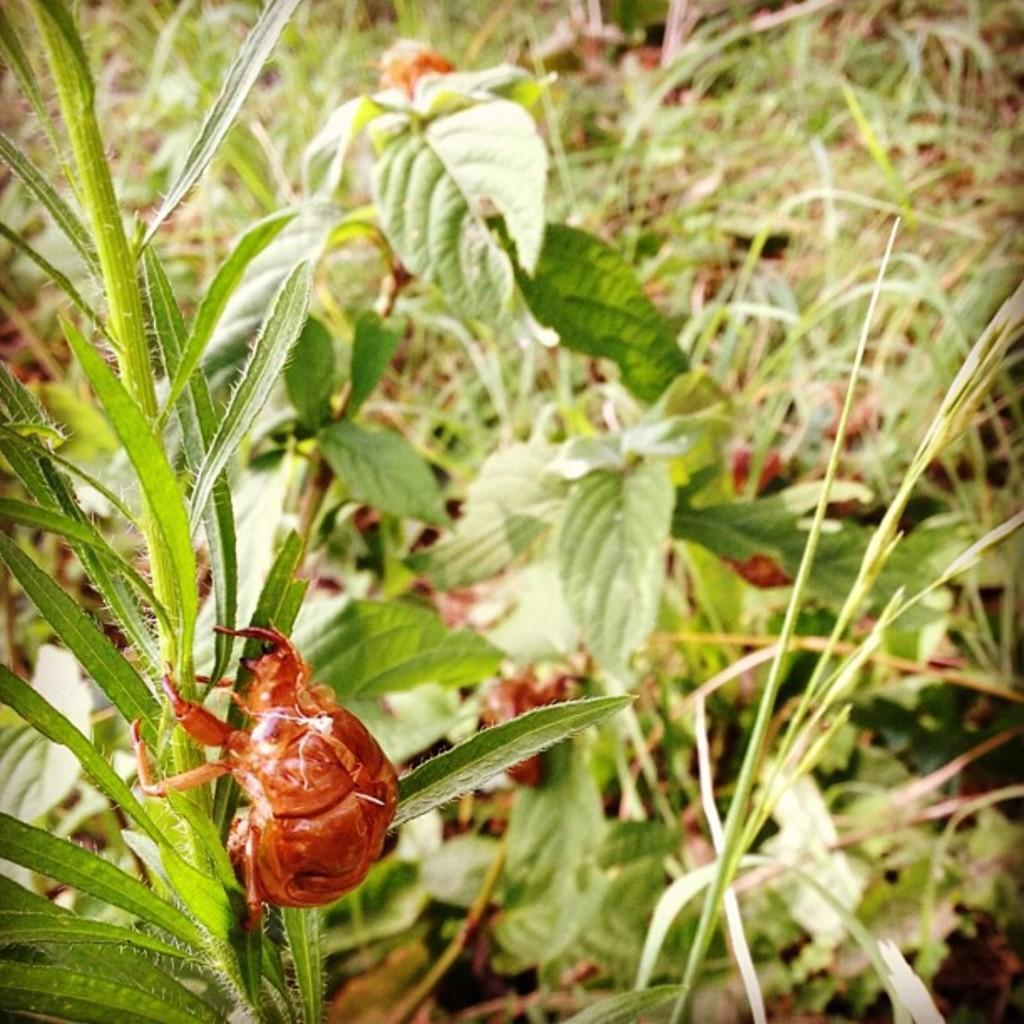What is the main subject of the image? There is a bug in the image. What is the bug doing in the image? The bug is climbing a plant. What else can be seen in the image besides the bug? There are many plants visible in the image. What type of wrench is the bug using to climb the plant in the image? There is no wrench present in the image; the bug is climbing the plant using its legs. How does the bug wash itself while climbing the plant in the image? The bug does not wash itself in the image; it is focused on climbing the plant. 